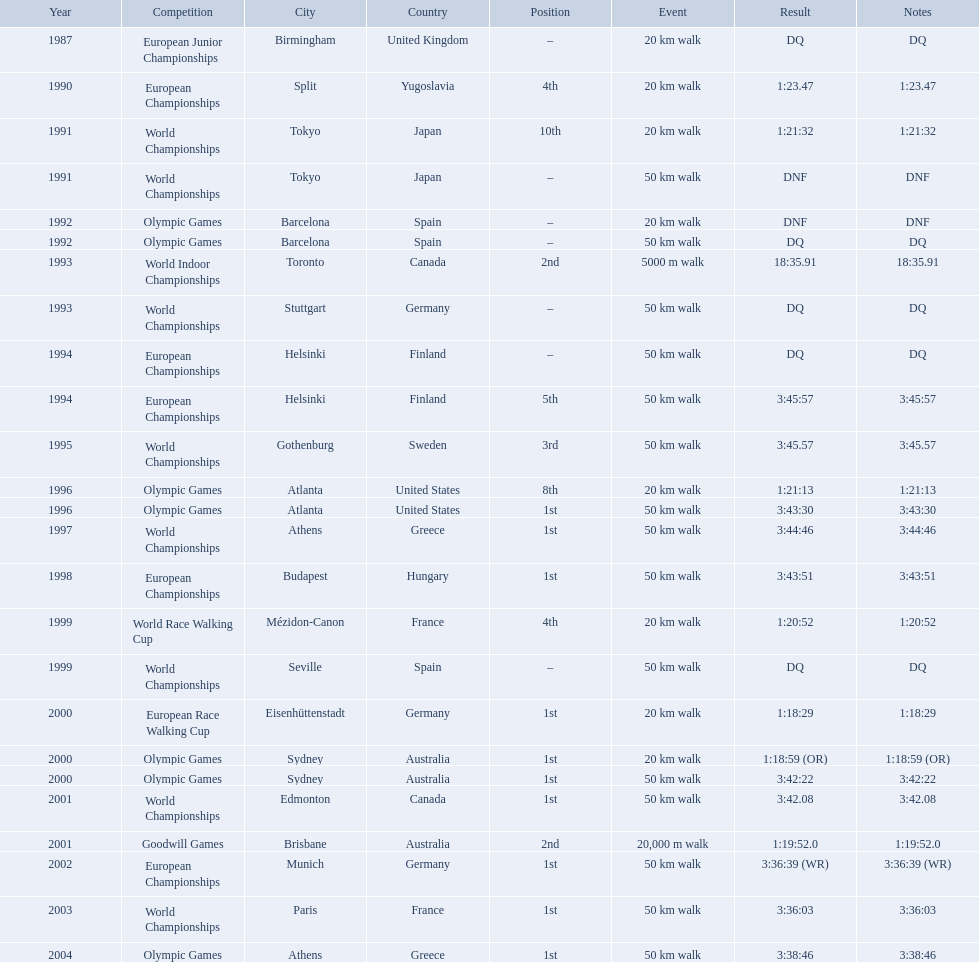What was the name of the competition that took place before the olympic games in 1996? World Championships. 